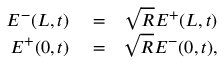<formula> <loc_0><loc_0><loc_500><loc_500>\begin{array} { r l r } { E ^ { - } ( L , t ) } & = } & { \sqrt { R } E ^ { + } ( L , t ) } \\ { E ^ { + } ( 0 , t ) } & = } & { \sqrt { R } E ^ { - } ( 0 , t ) , } \end{array}</formula> 